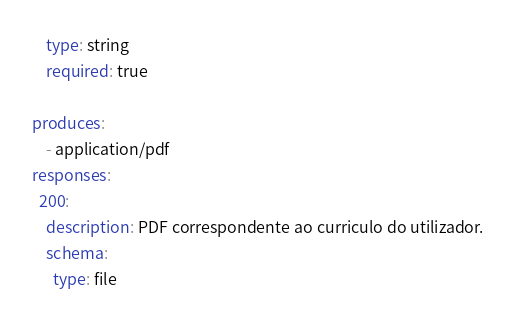<code> <loc_0><loc_0><loc_500><loc_500><_YAML_>    type: string
    required: true

produces:
    - application/pdf
responses:
  200:
    description: PDF correspondente ao curriculo do utilizador.
    schema:
      type: file</code> 